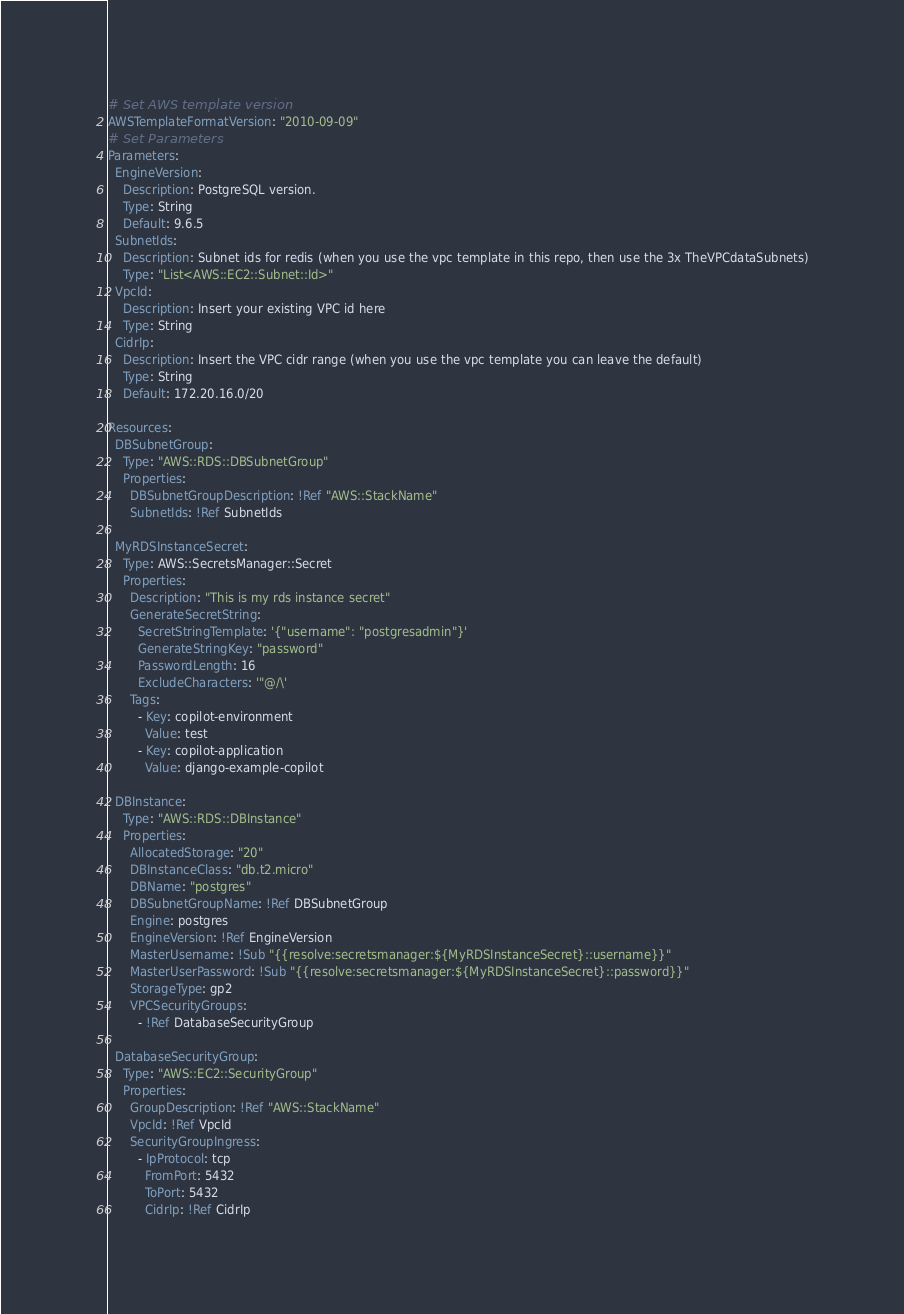Convert code to text. <code><loc_0><loc_0><loc_500><loc_500><_YAML_># Set AWS template version
AWSTemplateFormatVersion: "2010-09-09"
# Set Parameters
Parameters:
  EngineVersion:
    Description: PostgreSQL version.
    Type: String
    Default: 9.6.5
  SubnetIds:
    Description: Subnet ids for redis (when you use the vpc template in this repo, then use the 3x TheVPCdataSubnets)
    Type: "List<AWS::EC2::Subnet::Id>"
  VpcId:
    Description: Insert your existing VPC id here
    Type: String
  CidrIp:
    Description: Insert the VPC cidr range (when you use the vpc template you can leave the default)
    Type: String
    Default: 172.20.16.0/20

Resources:
  DBSubnetGroup:
    Type: "AWS::RDS::DBSubnetGroup"
    Properties:
      DBSubnetGroupDescription: !Ref "AWS::StackName"
      SubnetIds: !Ref SubnetIds

  MyRDSInstanceSecret:
    Type: AWS::SecretsManager::Secret
    Properties:
      Description: "This is my rds instance secret"
      GenerateSecretString:
        SecretStringTemplate: '{"username": "postgresadmin"}'
        GenerateStringKey: "password"
        PasswordLength: 16
        ExcludeCharacters: '"@/\'
      Tags:
        - Key: copilot-environment
          Value: test
        - Key: copilot-application
          Value: django-example-copilot

  DBInstance:
    Type: "AWS::RDS::DBInstance"
    Properties:
      AllocatedStorage: "20"
      DBInstanceClass: "db.t2.micro"
      DBName: "postgres"
      DBSubnetGroupName: !Ref DBSubnetGroup
      Engine: postgres
      EngineVersion: !Ref EngineVersion
      MasterUsername: !Sub "{{resolve:secretsmanager:${MyRDSInstanceSecret}::username}}"
      MasterUserPassword: !Sub "{{resolve:secretsmanager:${MyRDSInstanceSecret}::password}}"
      StorageType: gp2
      VPCSecurityGroups:
        - !Ref DatabaseSecurityGroup

  DatabaseSecurityGroup:
    Type: "AWS::EC2::SecurityGroup"
    Properties:
      GroupDescription: !Ref "AWS::StackName"
      VpcId: !Ref VpcId
      SecurityGroupIngress:
        - IpProtocol: tcp
          FromPort: 5432
          ToPort: 5432
          CidrIp: !Ref CidrIp
</code> 